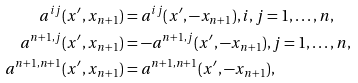Convert formula to latex. <formula><loc_0><loc_0><loc_500><loc_500>a ^ { i j } ( x ^ { \prime } , x _ { n + 1 } ) & = a ^ { i j } ( x ^ { \prime } , - x _ { n + 1 } ) , i , j = 1 , \dots , n , \\ a ^ { n + 1 , j } ( x ^ { \prime } , x _ { n + 1 } ) & = - a ^ { n + 1 , j } ( x ^ { \prime } , - x _ { n + 1 } ) , j = 1 , \dots , n , \\ a ^ { n + 1 , n + 1 } ( x ^ { \prime } , x _ { n + 1 } ) & = a ^ { n + 1 , n + 1 } ( x ^ { \prime } , - x _ { n + 1 } ) ,</formula> 